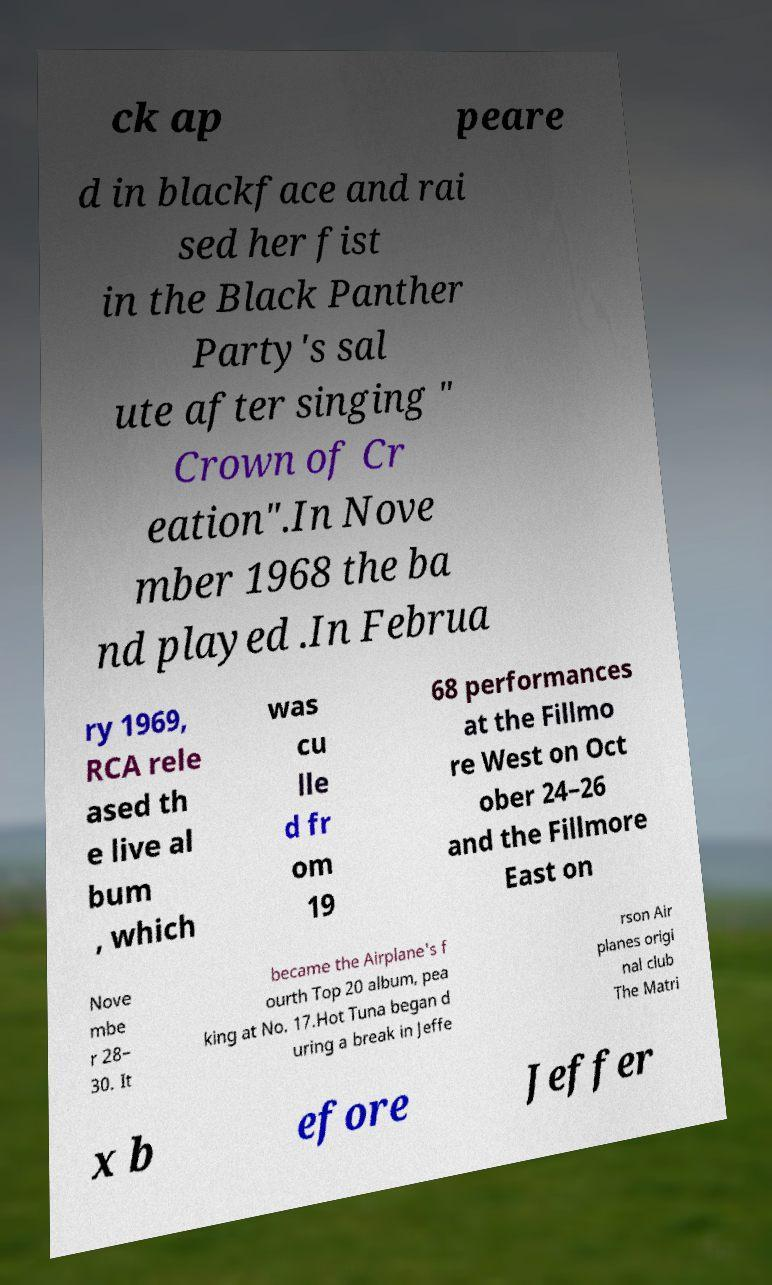Please identify and transcribe the text found in this image. ck ap peare d in blackface and rai sed her fist in the Black Panther Party's sal ute after singing " Crown of Cr eation".In Nove mber 1968 the ba nd played .In Februa ry 1969, RCA rele ased th e live al bum , which was cu lle d fr om 19 68 performances at the Fillmo re West on Oct ober 24–26 and the Fillmore East on Nove mbe r 28– 30. It became the Airplane's f ourth Top 20 album, pea king at No. 17.Hot Tuna began d uring a break in Jeffe rson Air planes origi nal club The Matri x b efore Jeffer 